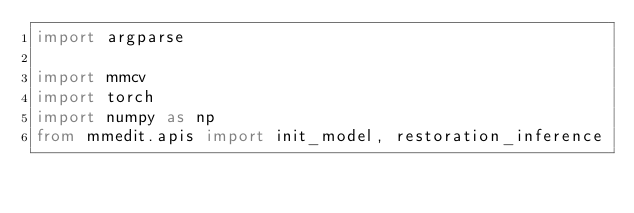<code> <loc_0><loc_0><loc_500><loc_500><_Python_>import argparse

import mmcv
import torch
import numpy as np
from mmedit.apis import init_model, restoration_inference</code> 